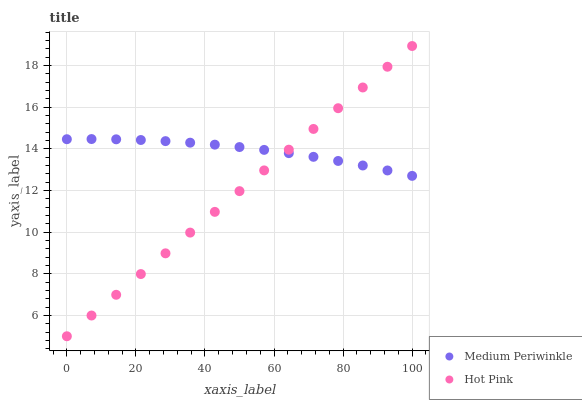Does Hot Pink have the minimum area under the curve?
Answer yes or no. Yes. Does Medium Periwinkle have the maximum area under the curve?
Answer yes or no. Yes. Does Medium Periwinkle have the minimum area under the curve?
Answer yes or no. No. Is Hot Pink the smoothest?
Answer yes or no. Yes. Is Medium Periwinkle the roughest?
Answer yes or no. Yes. Is Medium Periwinkle the smoothest?
Answer yes or no. No. Does Hot Pink have the lowest value?
Answer yes or no. Yes. Does Medium Periwinkle have the lowest value?
Answer yes or no. No. Does Hot Pink have the highest value?
Answer yes or no. Yes. Does Medium Periwinkle have the highest value?
Answer yes or no. No. Does Medium Periwinkle intersect Hot Pink?
Answer yes or no. Yes. Is Medium Periwinkle less than Hot Pink?
Answer yes or no. No. Is Medium Periwinkle greater than Hot Pink?
Answer yes or no. No. 